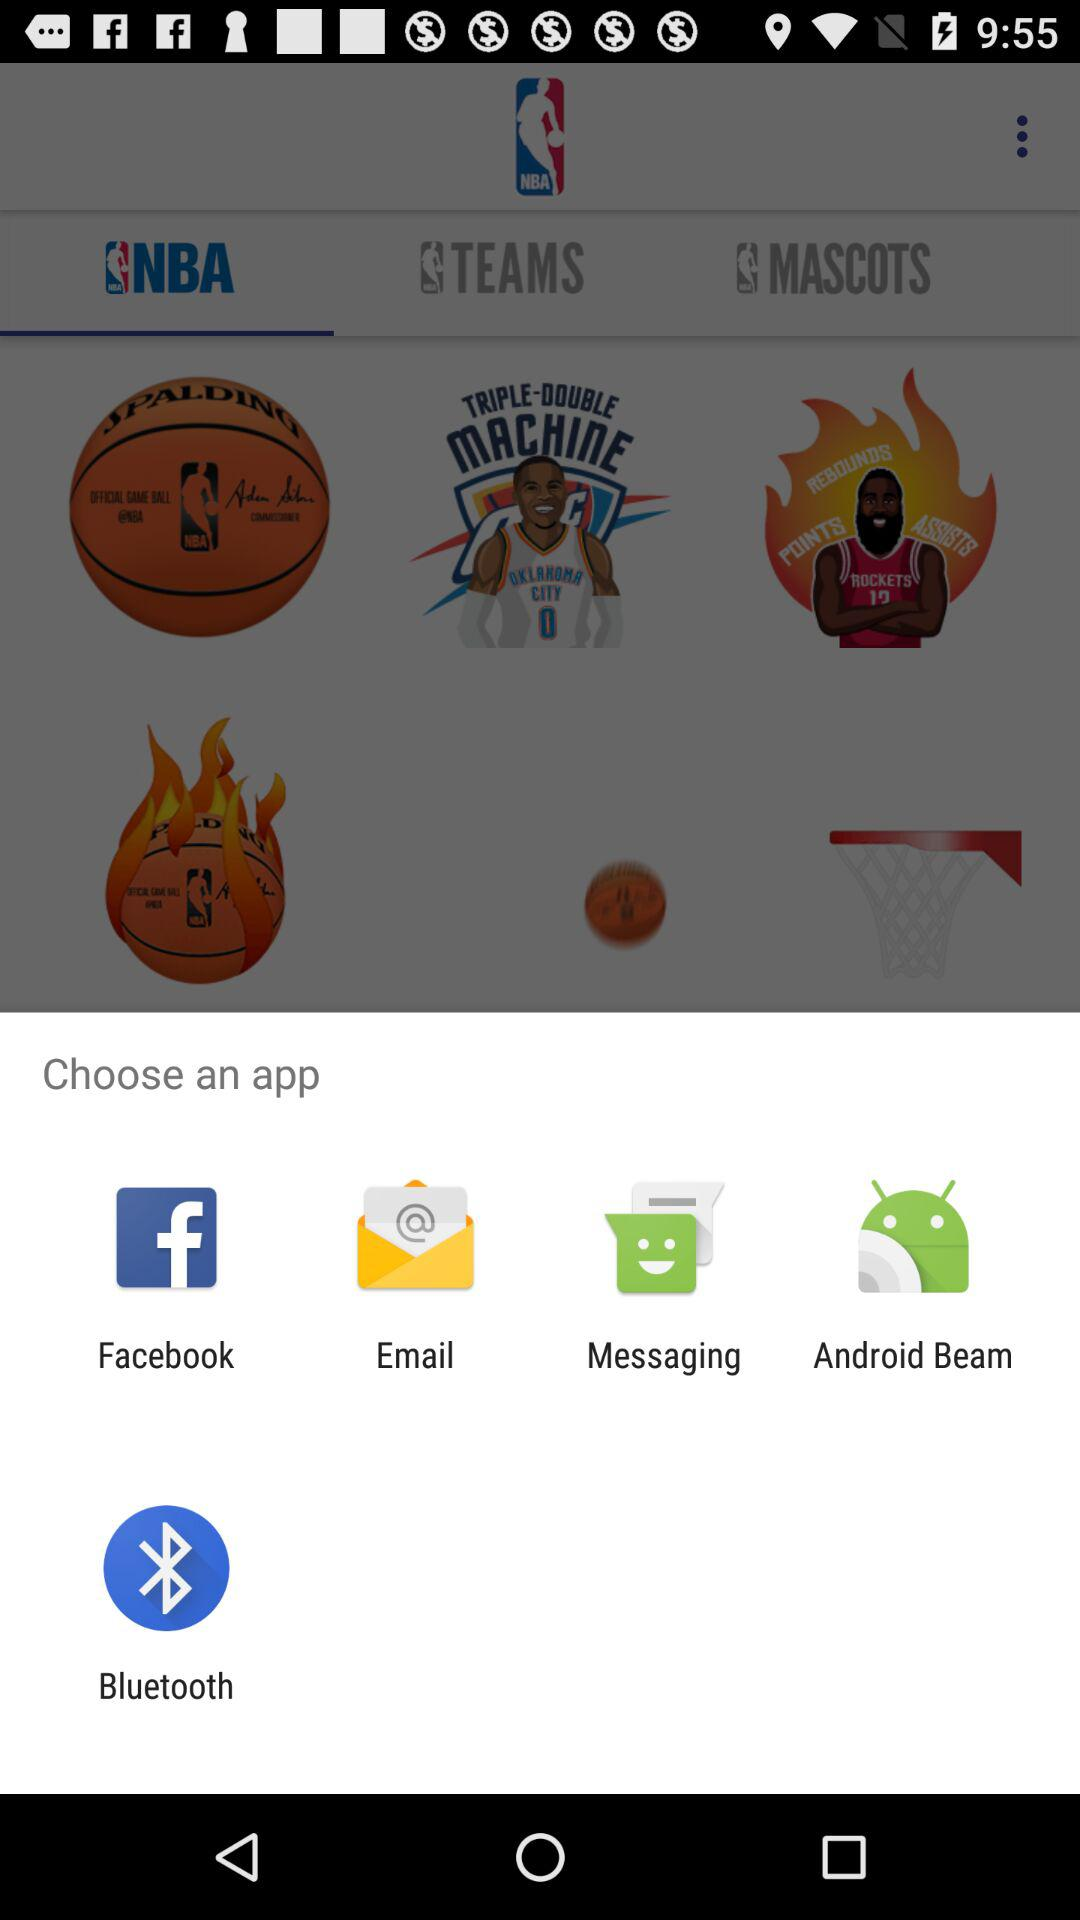Through which applications can we open it? The applications are "Facebook", "Email", "Messaging", "Android Beam" and "Bluetooth". 